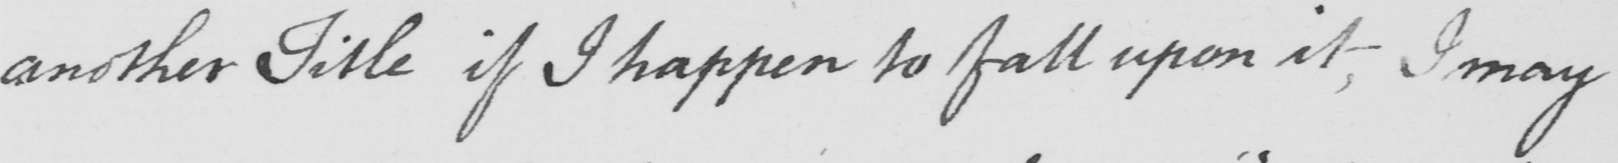Transcribe the text shown in this historical manuscript line. another Title if I happen to fall upon it, I may 